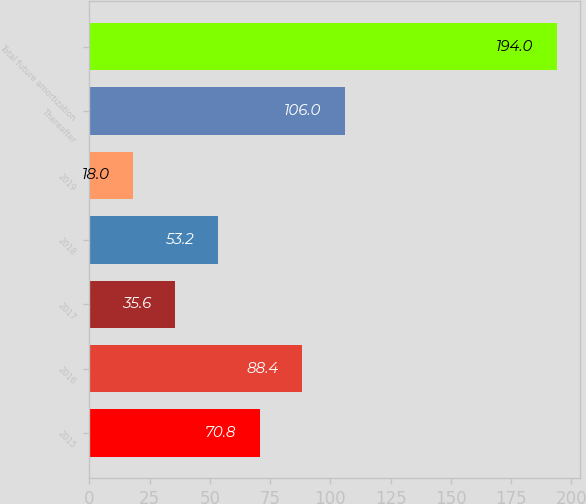<chart> <loc_0><loc_0><loc_500><loc_500><bar_chart><fcel>2015<fcel>2016<fcel>2017<fcel>2018<fcel>2019<fcel>Thereafter<fcel>Total future amortization<nl><fcel>70.8<fcel>88.4<fcel>35.6<fcel>53.2<fcel>18<fcel>106<fcel>194<nl></chart> 